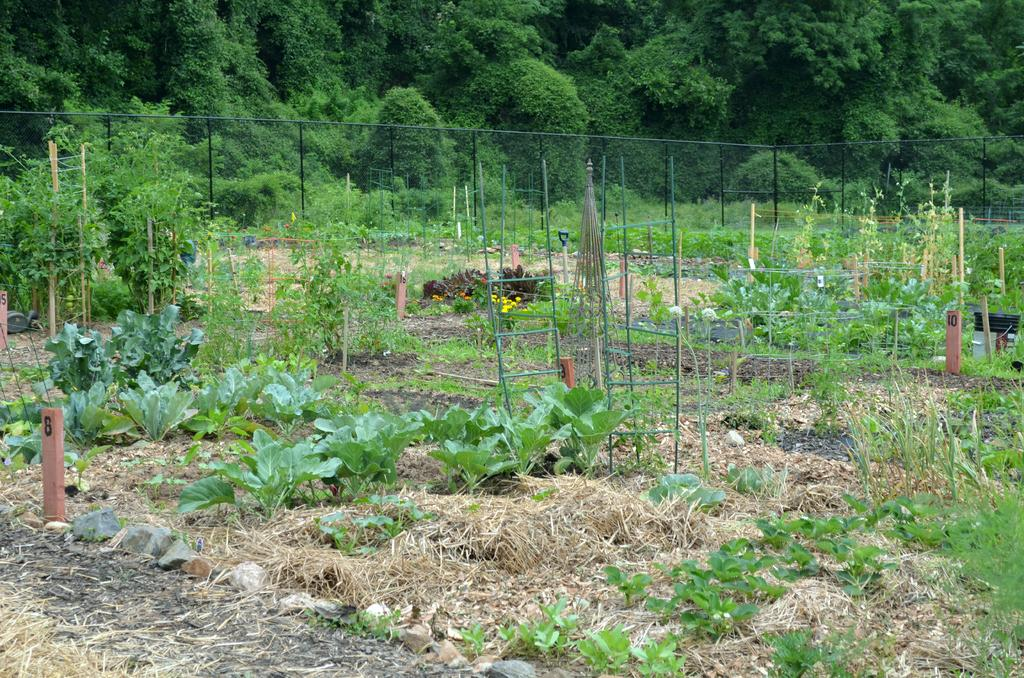What type of vegetation can be seen in the image? There are plants and trees in the image. What is unique about the grass in the image? The grass in the image is yellow. What type of barrier is present in the image? There is fencing in the image. What other objects can be seen in the image? There are poles in the image, some of which have numbers written on them. What else is visible on the ground in the image? There are other things visible on the ground, but their specific nature is not mentioned in the facts. What type of cake is being served on the ground in the image? There is no cake present in the image. What color is the rose on the ground in the image? There is no rose present in the image. 